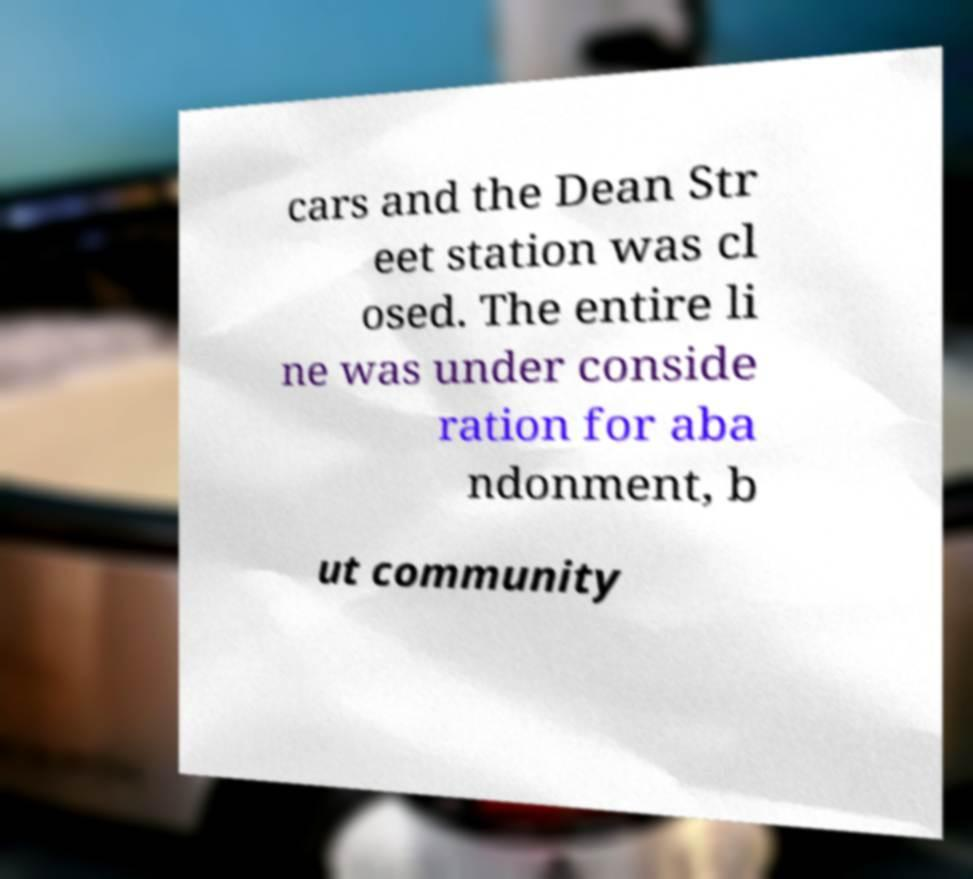Can you read and provide the text displayed in the image?This photo seems to have some interesting text. Can you extract and type it out for me? cars and the Dean Str eet station was cl osed. The entire li ne was under conside ration for aba ndonment, b ut community 